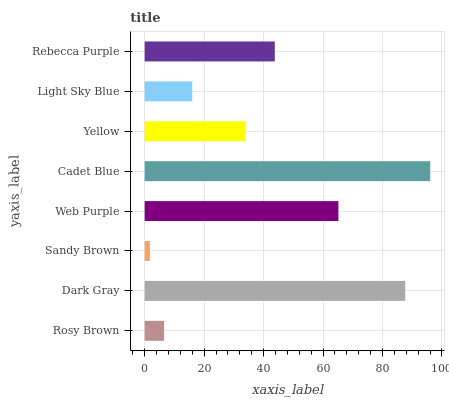Is Sandy Brown the minimum?
Answer yes or no. Yes. Is Cadet Blue the maximum?
Answer yes or no. Yes. Is Dark Gray the minimum?
Answer yes or no. No. Is Dark Gray the maximum?
Answer yes or no. No. Is Dark Gray greater than Rosy Brown?
Answer yes or no. Yes. Is Rosy Brown less than Dark Gray?
Answer yes or no. Yes. Is Rosy Brown greater than Dark Gray?
Answer yes or no. No. Is Dark Gray less than Rosy Brown?
Answer yes or no. No. Is Rebecca Purple the high median?
Answer yes or no. Yes. Is Yellow the low median?
Answer yes or no. Yes. Is Dark Gray the high median?
Answer yes or no. No. Is Cadet Blue the low median?
Answer yes or no. No. 